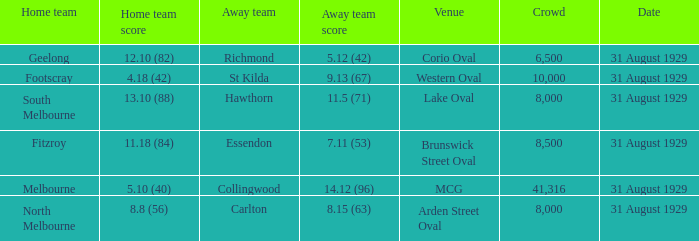What date was the game when the away team was carlton? 31 August 1929. 